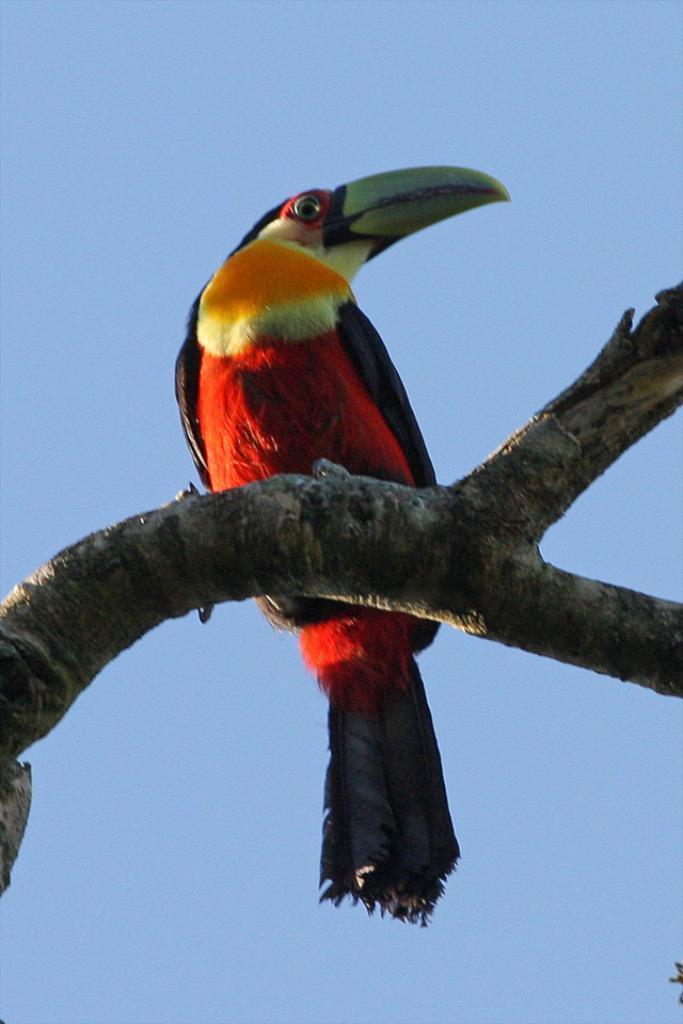How would you summarize this image in a sentence or two? Here we can see a bird on a branch and this is sky 